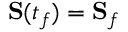<formula> <loc_0><loc_0><loc_500><loc_500>S ( t _ { f } ) = S _ { f }</formula> 